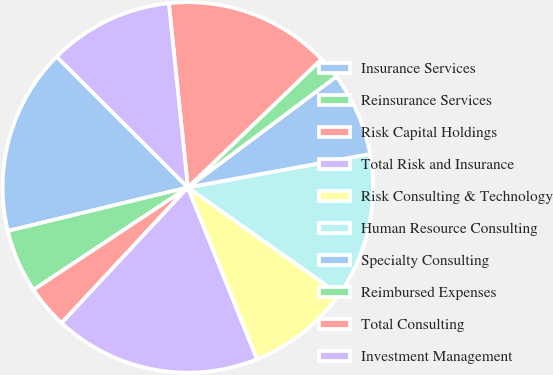<chart> <loc_0><loc_0><loc_500><loc_500><pie_chart><fcel>Insurance Services<fcel>Reinsurance Services<fcel>Risk Capital Holdings<fcel>Total Risk and Insurance<fcel>Risk Consulting & Technology<fcel>Human Resource Consulting<fcel>Specialty Consulting<fcel>Reimbursed Expenses<fcel>Total Consulting<fcel>Investment Management<nl><fcel>16.25%<fcel>5.54%<fcel>3.75%<fcel>18.03%<fcel>9.11%<fcel>12.68%<fcel>7.32%<fcel>1.97%<fcel>14.46%<fcel>10.89%<nl></chart> 